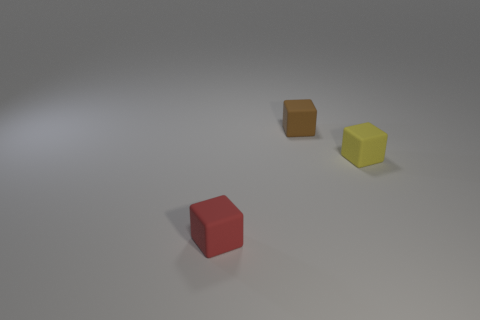If the red cube is considered the reference point, where are the other cubes located in relation to it? Relative to the red cube, the orange cube is positioned to the right and slightly behind from the camera's perspective, and the yellow cube is further back and to the right, maintaining a diagonal configuration. 